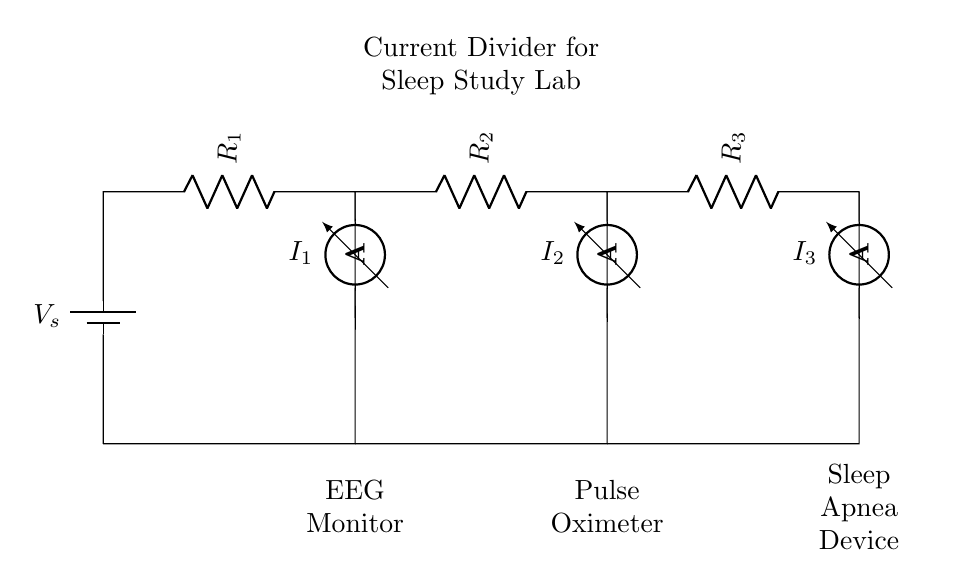What is the total voltage supplied to the circuit? The total voltage supplied to the circuit is the same as the battery voltage, represented as V_s in the diagram.
Answer: V_s What are the resistances in the circuit? The resistances in the circuit are R_1, R_2, and R_3. These are the components that control the current distribution among the devices.
Answer: R_1, R_2, R_3 What is the purpose of the ammeters in the circuit? The ammeters are used to measure the current flowing through each resistor, allowing for monitoring of power distribution to the devices.
Answer: Measure current Which medical devices are powered by this circuit? The devices powered by this circuit are an EEG Monitor, a Pulse Oximeter, and a Sleep Apnea Device, each connected in parallel to the current divider.
Answer: EEG Monitor, Pulse Oximeter, Sleep Apnea Device How does the current divider affect the current distribution? The current divider ensures that the total current from the supply is split among the branches based on the resistance values of R_1, R_2, and R_3, influencing how much current each device receives.
Answer: Distributes current What is the relationship between the resistances and the currents flowing to each device? According to the current divider rule, the current flowing through each resistor is inversely proportional to its resistance, meaning lower resistance receives more current and vice versa.
Answer: Inverse relationship 